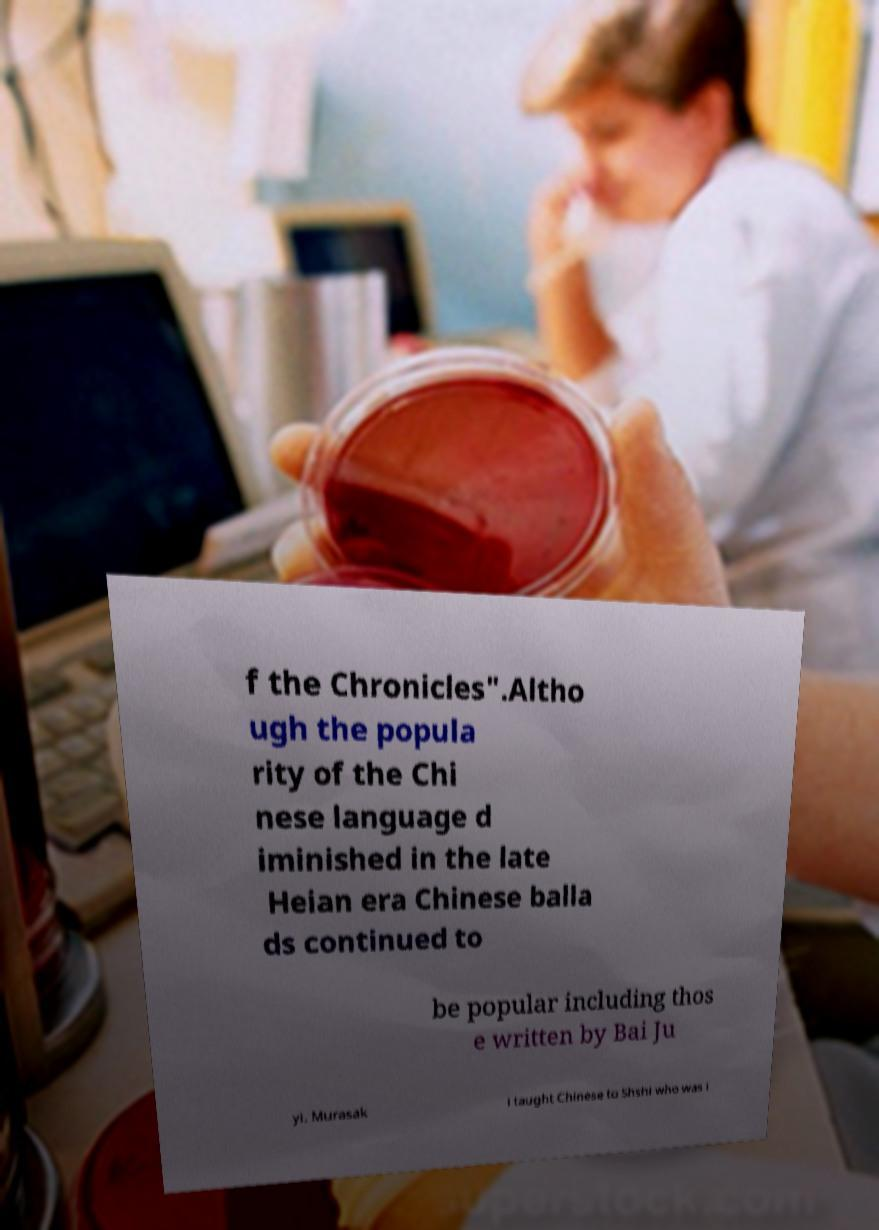There's text embedded in this image that I need extracted. Can you transcribe it verbatim? f the Chronicles".Altho ugh the popula rity of the Chi nese language d iminished in the late Heian era Chinese balla ds continued to be popular including thos e written by Bai Ju yi. Murasak i taught Chinese to Shshi who was i 